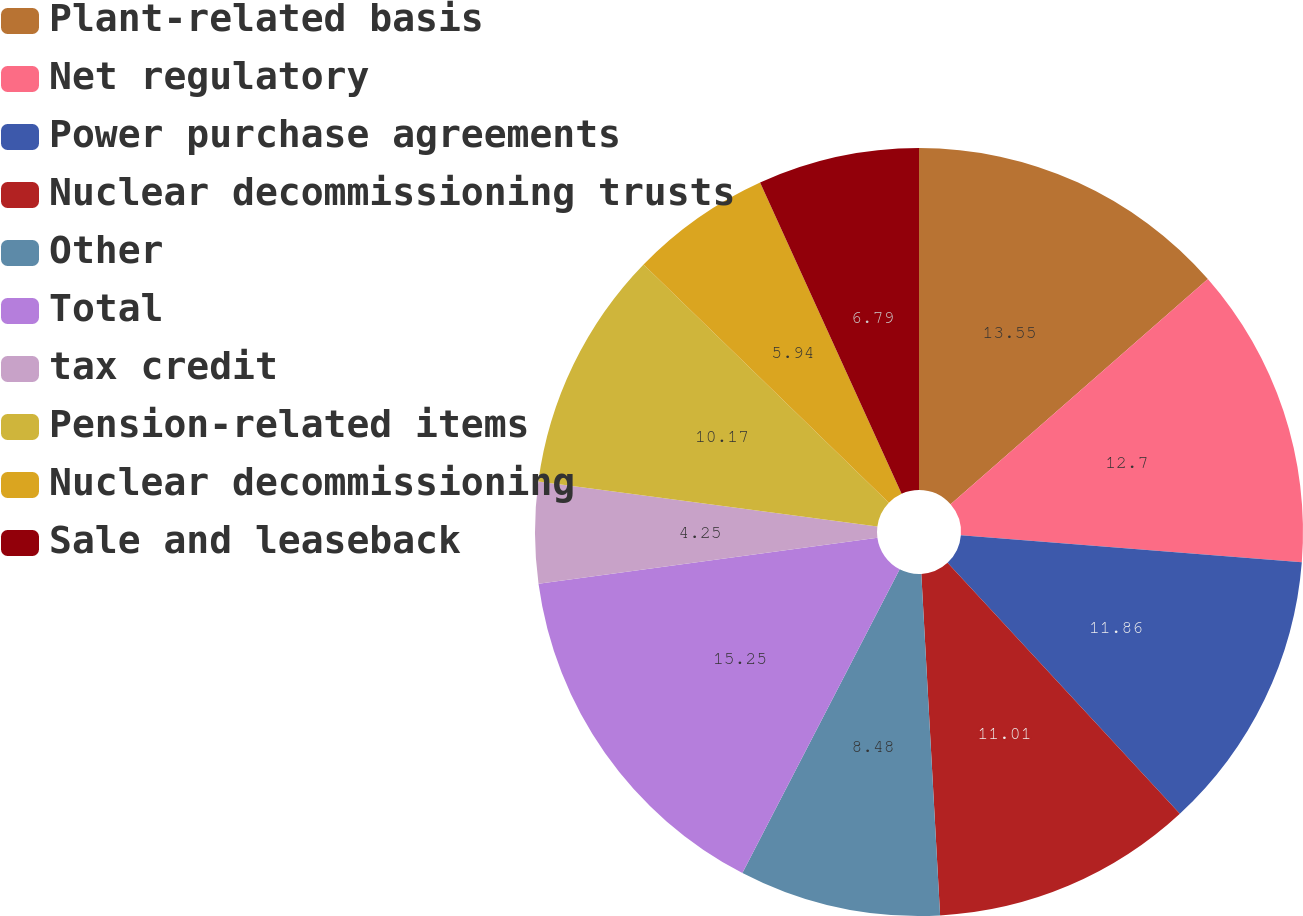Convert chart to OTSL. <chart><loc_0><loc_0><loc_500><loc_500><pie_chart><fcel>Plant-related basis<fcel>Net regulatory<fcel>Power purchase agreements<fcel>Nuclear decommissioning trusts<fcel>Other<fcel>Total<fcel>tax credit<fcel>Pension-related items<fcel>Nuclear decommissioning<fcel>Sale and leaseback<nl><fcel>13.55%<fcel>12.7%<fcel>11.86%<fcel>11.01%<fcel>8.48%<fcel>15.24%<fcel>4.25%<fcel>10.17%<fcel>5.94%<fcel>6.79%<nl></chart> 